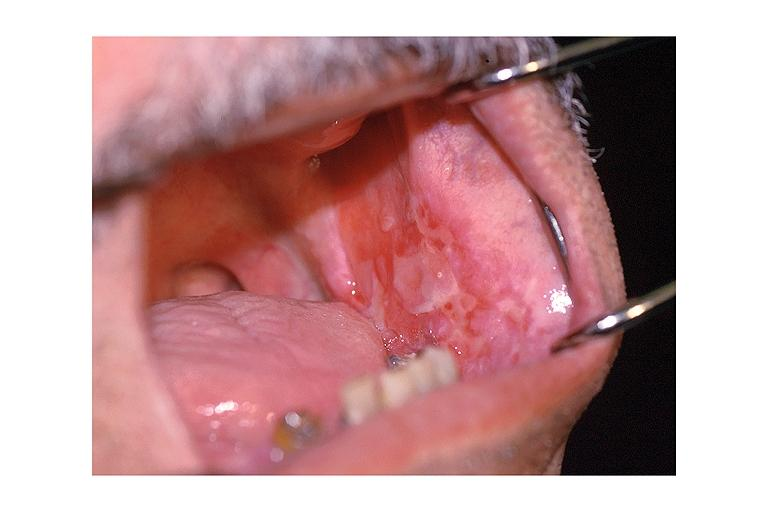s oral present?
Answer the question using a single word or phrase. Yes 